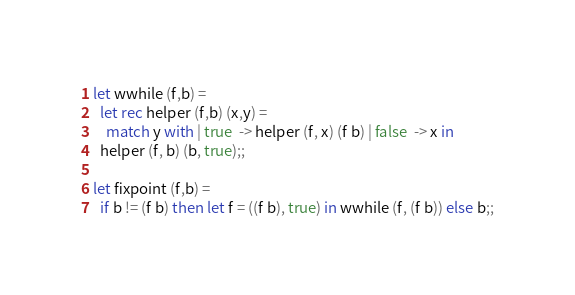Convert code to text. <code><loc_0><loc_0><loc_500><loc_500><_OCaml_>
let wwhile (f,b) =
  let rec helper (f,b) (x,y) =
    match y with | true  -> helper (f, x) (f b) | false  -> x in
  helper (f, b) (b, true);;

let fixpoint (f,b) =
  if b != (f b) then let f = ((f b), true) in wwhile (f, (f b)) else b;;
</code> 